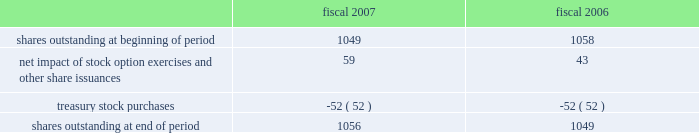Morgan stanley notes to consolidated financial statements 2014 ( continued ) 16 .
Shareholders 2019 equity .
Common stock .
Changes in shares of common stock outstanding for fiscal 2007 and fiscal 2006 were as follows ( share data in millions ) : fiscal fiscal .
Treasury shares .
During fiscal 2007 , the company purchased $ 3.8 billion of its common stock through open market purchases at an average cost of $ 72.65 per share .
During fiscal 2006 , the company purchased $ 3.4 billion of its common stock through open market purchases at an average cost of $ 65.43 per share .
In december 2006 , the company announced that its board of directors had authorized the repurchase of up to $ 6 billion of the company 2019s outstanding common stock .
This share repurchase authorization considers , among other things , business segment capital needs , as well as equity-based compensation and benefit plan requirements .
As of november 30 , 2007 , the company had approximately $ 2.3 billion remaining under its current share repurchase authorization .
Rabbi trusts .
The company has established rabbi trusts ( the 201crabbi trusts 201d ) to provide common stock voting rights to certain employees who hold outstanding restricted stock units .
The number of shares of common stock outstanding in the rabbi trusts was approximately 107 million at november 30 , 2007 and approximately 81 million at november 30 , 2006 .
The assets of the rabbi trusts are consolidated with those of the company , and the value of the company 2019s stock held in the rabbi trusts is classified in shareholders 2019 equity and generally accounted for in a manner similar to treasury stock .
Preferred stock .
In july 2006 , the company issued 44000000 depositary shares , in an aggregate of $ 1100 million .
Each depositary share represents 1/1000th of a share of floating rate non-cumulative preferred stock , series a , $ 0.01 par value ( 201cseries a preferred stock 201d ) .
The series a preferred stock is redeemable at the company 2019s option , in whole or in part , on or after july 15 , 2011 at a redemption price of $ 25000 per share ( equivalent to $ 25 per depositary share ) .
The series a preferred stock also has a preference over the company 2019s common stock upon liquidation .
Subsequent to fiscal year-end , the company declared a quarterly dividend of $ 379.66 per share of series a preferred stock that was paid on january 15 , 2008 to preferred shareholders of record on december 31 , 2007 .
Regulatory requirements .
On april 1 , 2007 , the company merged msdwi into ms&co .
Upon completion of the merger , the surviving entity , ms&co. , became the company 2019s principal u.s .
Broker-dealer .
Ms&co .
Is a registered broker-dealer and registered futures commission merchant and , accordingly , is subject to the minimum net capital requirements of the securities and exchange commission ( the 201csec 201d ) , the financial industry regulatory authority and the commodity futures trading commission .
Ms&co .
Has consistently operated in excess of these requirements .
Ms&co . 2019s net capital totaled $ 6673 million at november 30 , 2007 , which exceeded the amount required by $ 4950 million .
Msip , a london-based broker-dealer subsidiary , is subject to the capital requirements of the financial services authority , and msjs , a tokyo-based broker-dealer subsidiary , is subject to the capital requirements of the financial services agency .
Msip and msjs consistently operated in excess of their respective regulatory capital requirements. .
What was the net change in common stock outstanding in millions between 2006 and 2007? 
Computations: (1056 - 1049)
Answer: 7.0. 